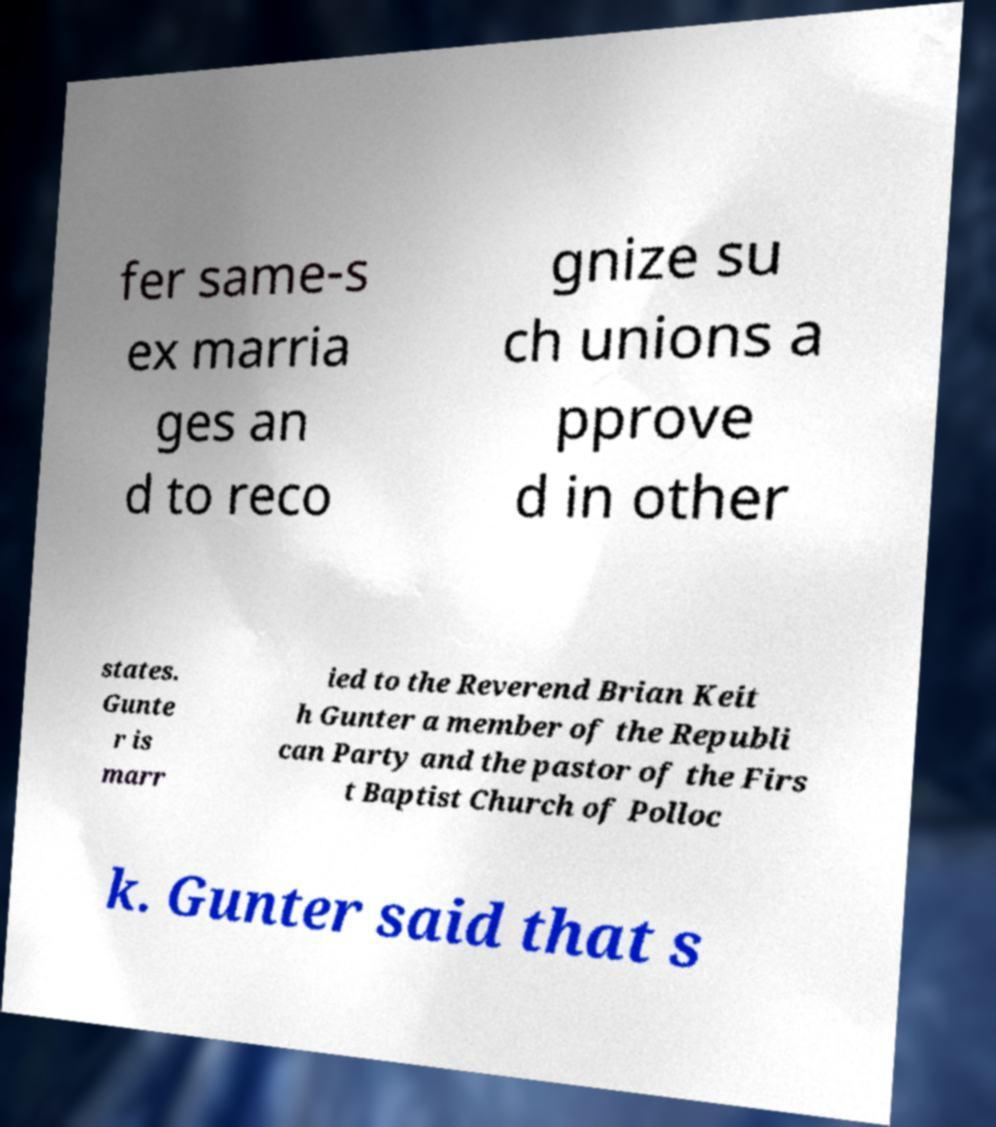There's text embedded in this image that I need extracted. Can you transcribe it verbatim? fer same-s ex marria ges an d to reco gnize su ch unions a pprove d in other states. Gunte r is marr ied to the Reverend Brian Keit h Gunter a member of the Republi can Party and the pastor of the Firs t Baptist Church of Polloc k. Gunter said that s 